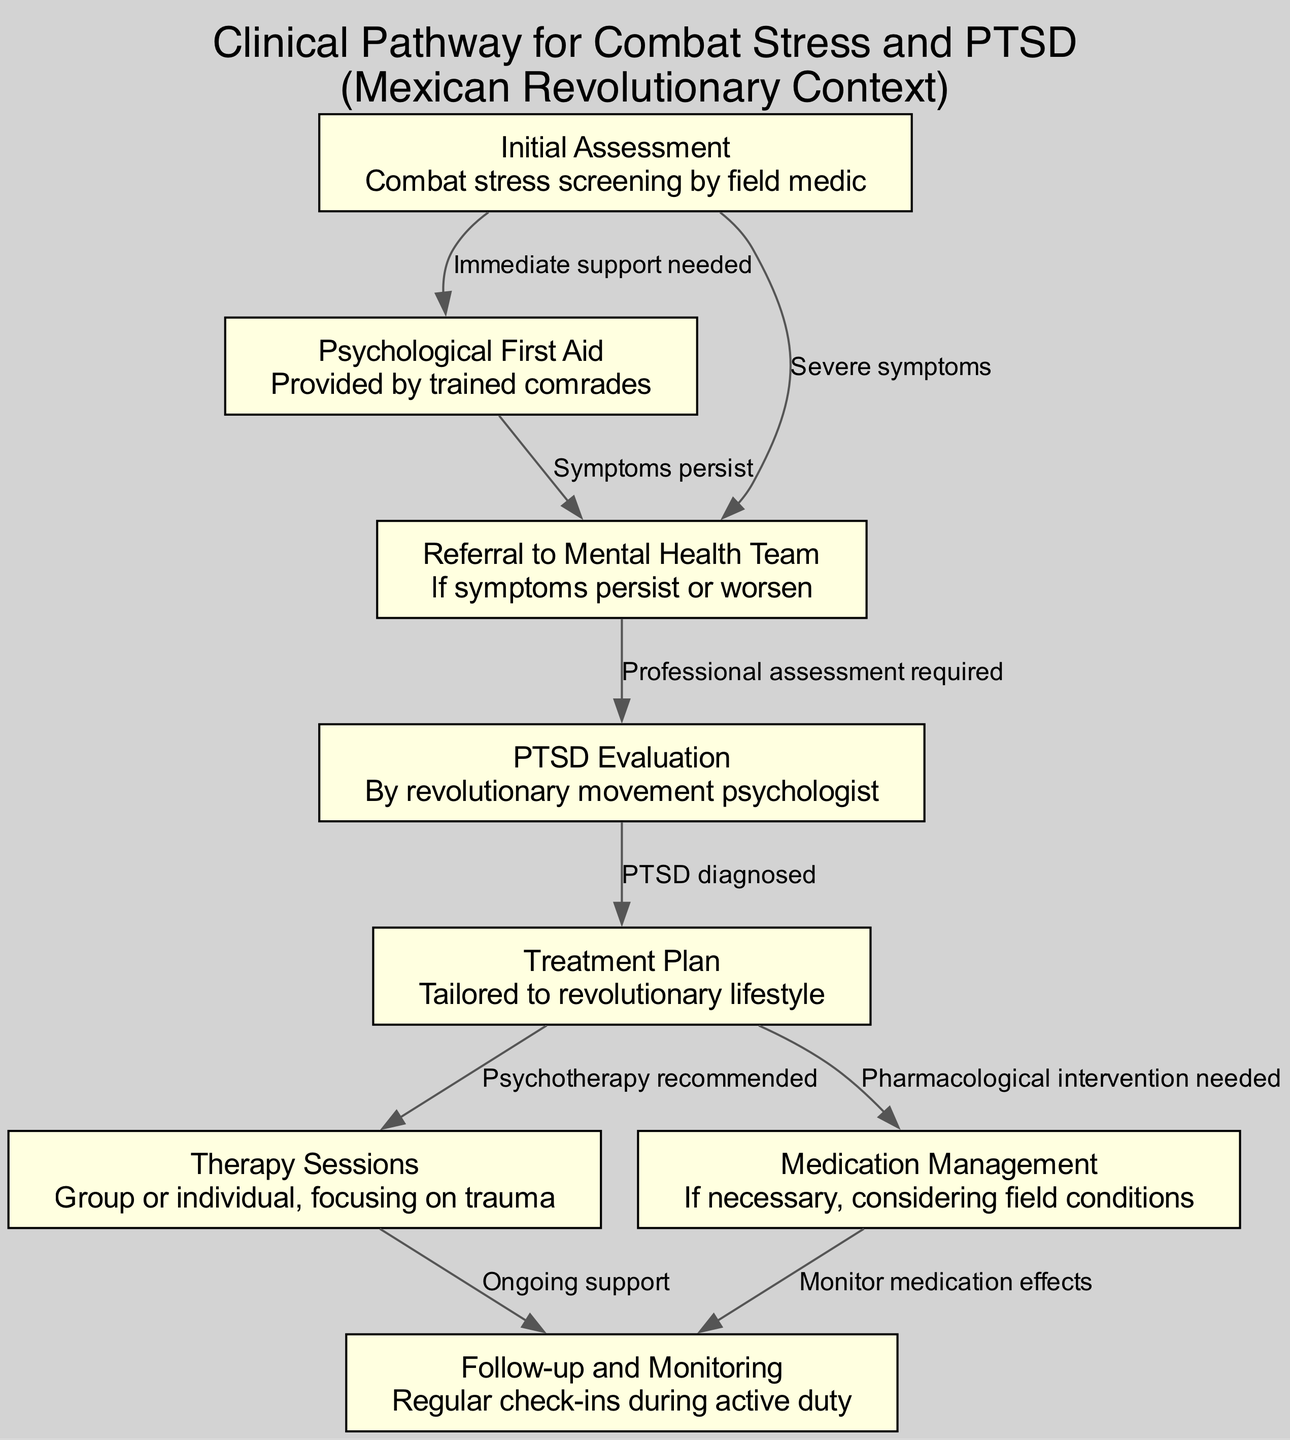What is the first step in the clinical pathway? The first step is identified in the diagram as "Initial Assessment". This node represents the initial action taken when assessing combat stress.
Answer: Initial Assessment How many therapy sessions are mentioned in the pathway? There is one node labeled "Therapy Sessions", indicating there is a singular focus on therapy within the pathway.
Answer: 1 What does "Medication Management" lead to? The "Medication Management" node leads to the "Follow-up and Monitoring" node, which implies that if medication is administered, there will be regular monitoring afterward.
Answer: Follow-up and Monitoring What type of evaluation follows the referral to the mental health team? After the referral to the mental health team, the next step is "PTSD Evaluation". This step specifically conducts an evaluation for PTSD.
Answer: PTSD Evaluation What is required if symptoms persist after Psychological First Aid? If symptoms persist after "Psychological First Aid", a referral to the mental health team is required according to the connections in the diagram.
Answer: Referral to Mental Health Team What happens after a PTSD diagnosis? Once PTSD is diagnosed (after the "PTSD Evaluation" step), a "Treatment Plan" is created tailored to the revolutionary lifestyle.
Answer: Treatment Plan What are the two possible interventions that can follow the treatment plan? Following a treatment plan, the pathway allows for two possible interventions: "Therapy Sessions" and "Medication Management". Both options focus on addressing the outlined needs.
Answer: Therapy Sessions and Medication Management How many edges connect to the "Initial Assessment" node? The "Initial Assessment" node is connected to two edges: one leading to "Psychological First Aid" and another leading to "Referral to Mental Health Team".
Answer: 2 What type of support is indicated after therapy sessions? The pathway indicates that "Ongoing support" follows therapy sessions, ensuring continued assistance for the individual.
Answer: Ongoing support 